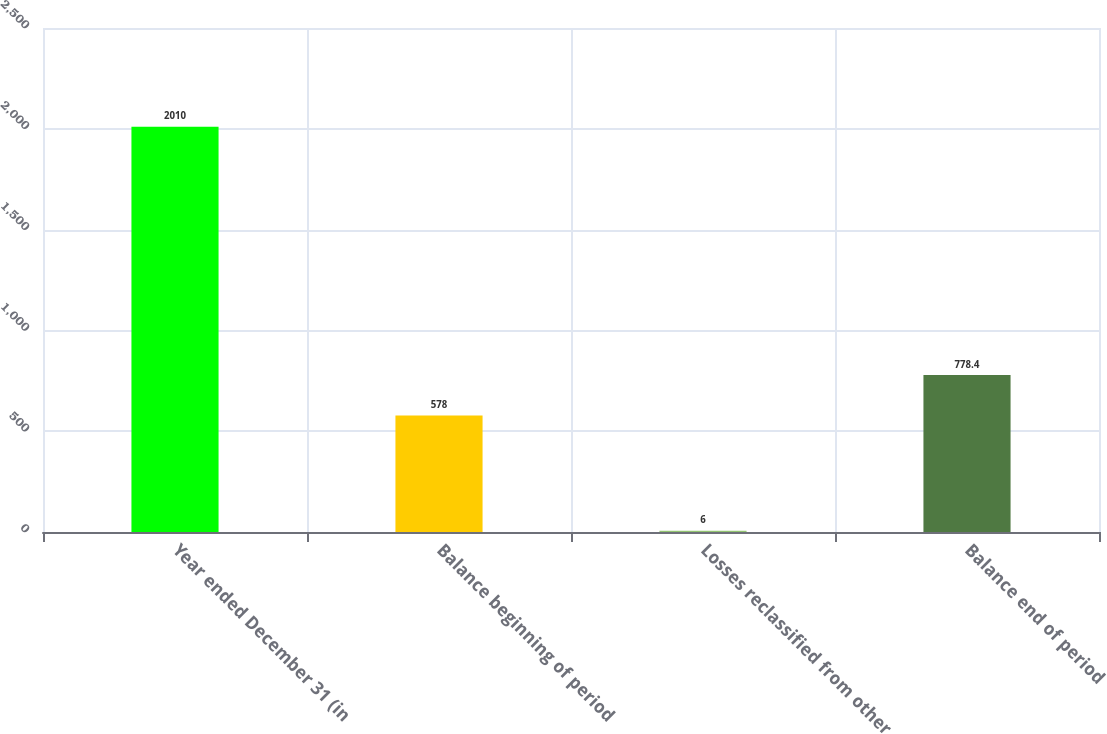<chart> <loc_0><loc_0><loc_500><loc_500><bar_chart><fcel>Year ended December 31 (in<fcel>Balance beginning of period<fcel>Losses reclassified from other<fcel>Balance end of period<nl><fcel>2010<fcel>578<fcel>6<fcel>778.4<nl></chart> 